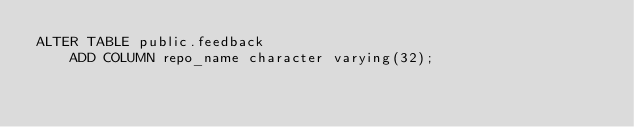<code> <loc_0><loc_0><loc_500><loc_500><_SQL_>ALTER TABLE public.feedback
    ADD COLUMN repo_name character varying(32);</code> 